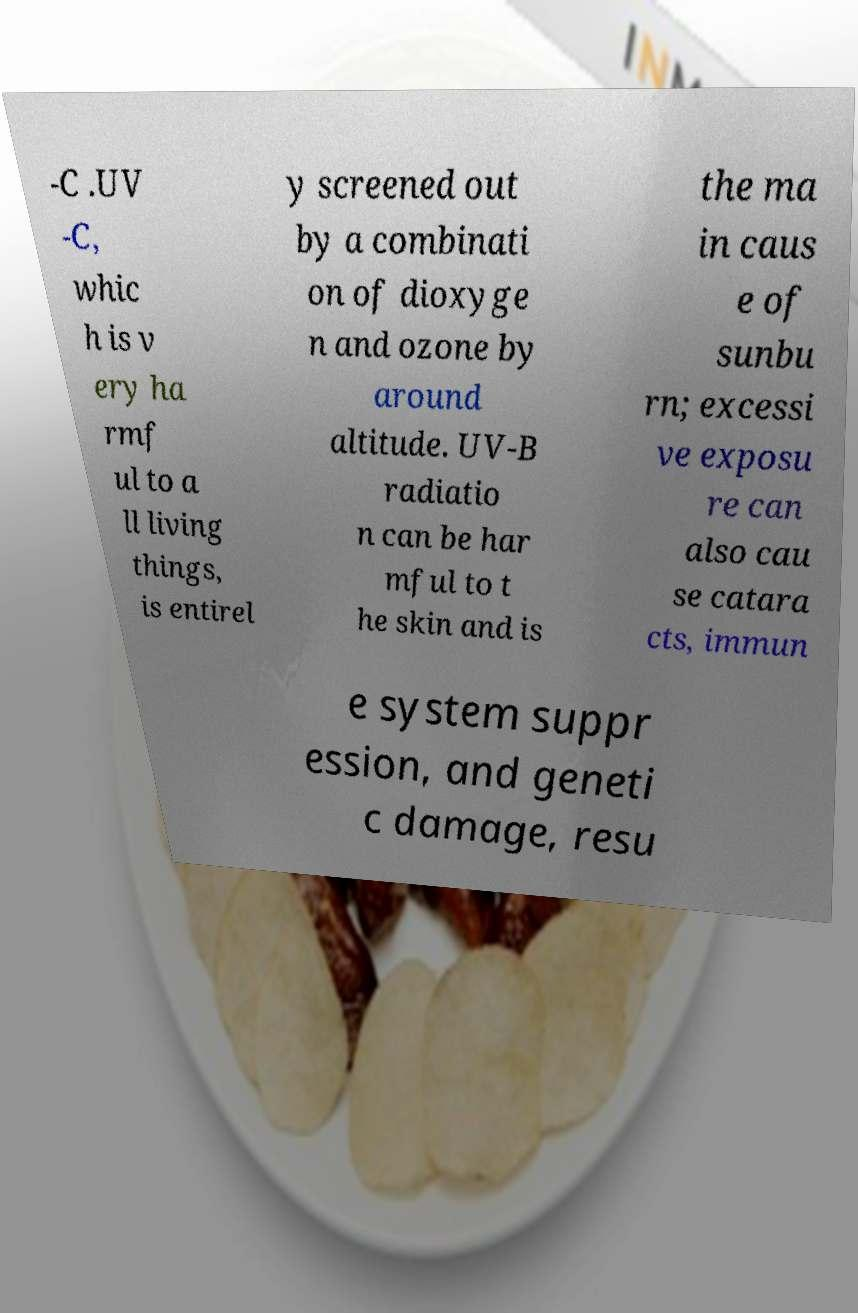Can you read and provide the text displayed in the image?This photo seems to have some interesting text. Can you extract and type it out for me? -C .UV -C, whic h is v ery ha rmf ul to a ll living things, is entirel y screened out by a combinati on of dioxyge n and ozone by around altitude. UV-B radiatio n can be har mful to t he skin and is the ma in caus e of sunbu rn; excessi ve exposu re can also cau se catara cts, immun e system suppr ession, and geneti c damage, resu 